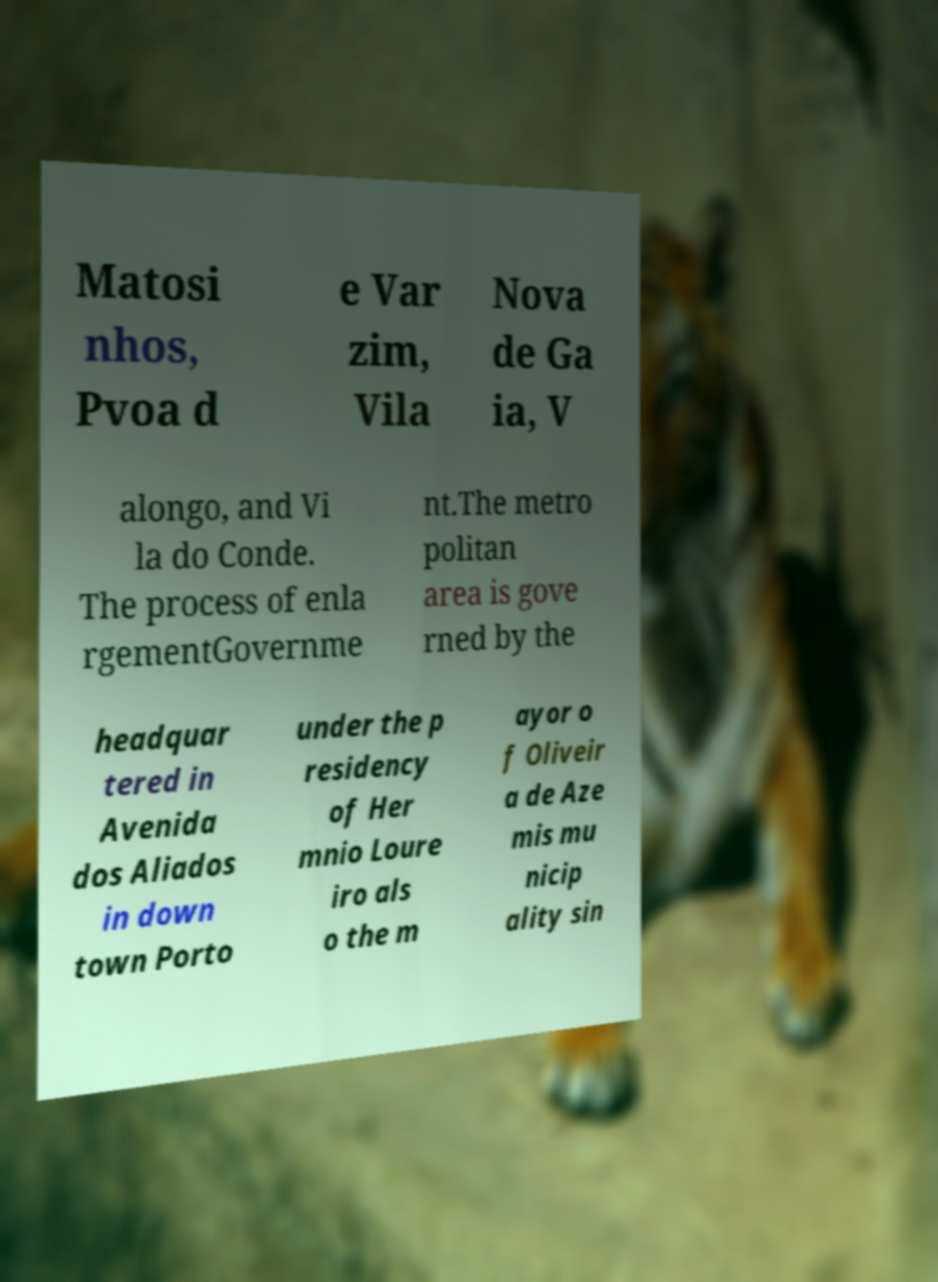Could you assist in decoding the text presented in this image and type it out clearly? Matosi nhos, Pvoa d e Var zim, Vila Nova de Ga ia, V alongo, and Vi la do Conde. The process of enla rgementGovernme nt.The metro politan area is gove rned by the headquar tered in Avenida dos Aliados in down town Porto under the p residency of Her mnio Loure iro als o the m ayor o f Oliveir a de Aze mis mu nicip ality sin 